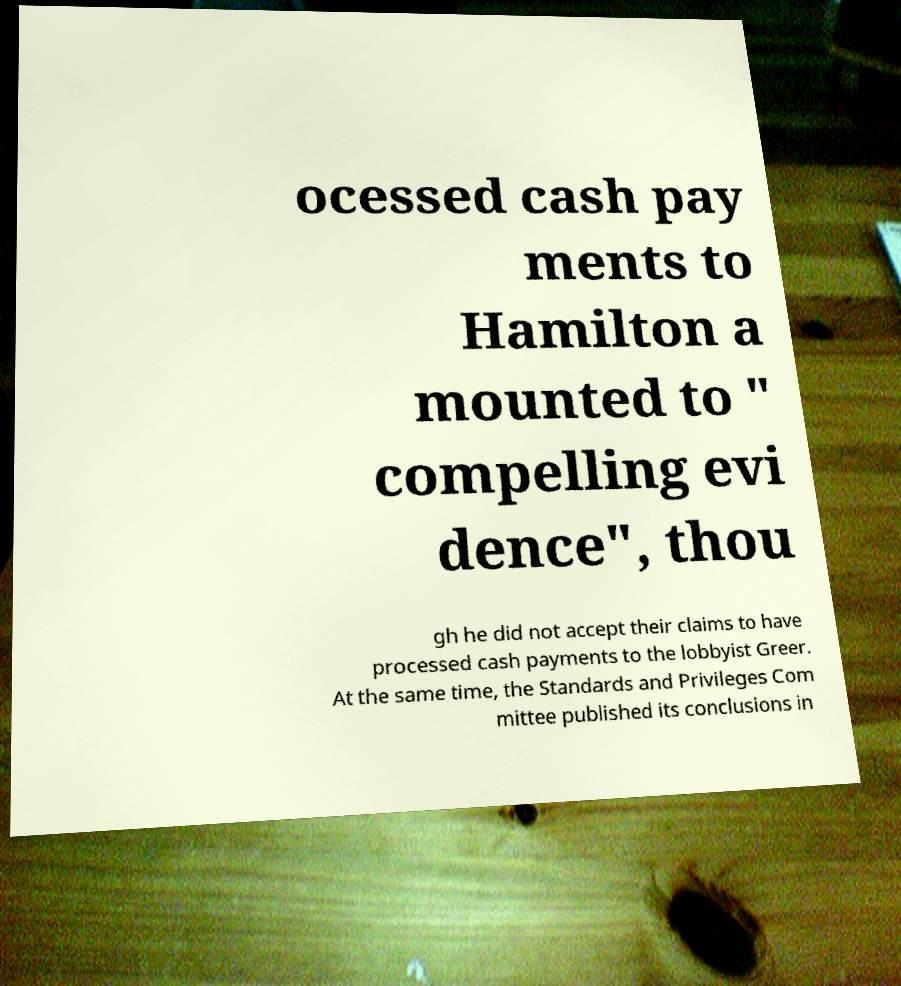What messages or text are displayed in this image? I need them in a readable, typed format. ocessed cash pay ments to Hamilton a mounted to " compelling evi dence", thou gh he did not accept their claims to have processed cash payments to the lobbyist Greer. At the same time, the Standards and Privileges Com mittee published its conclusions in 